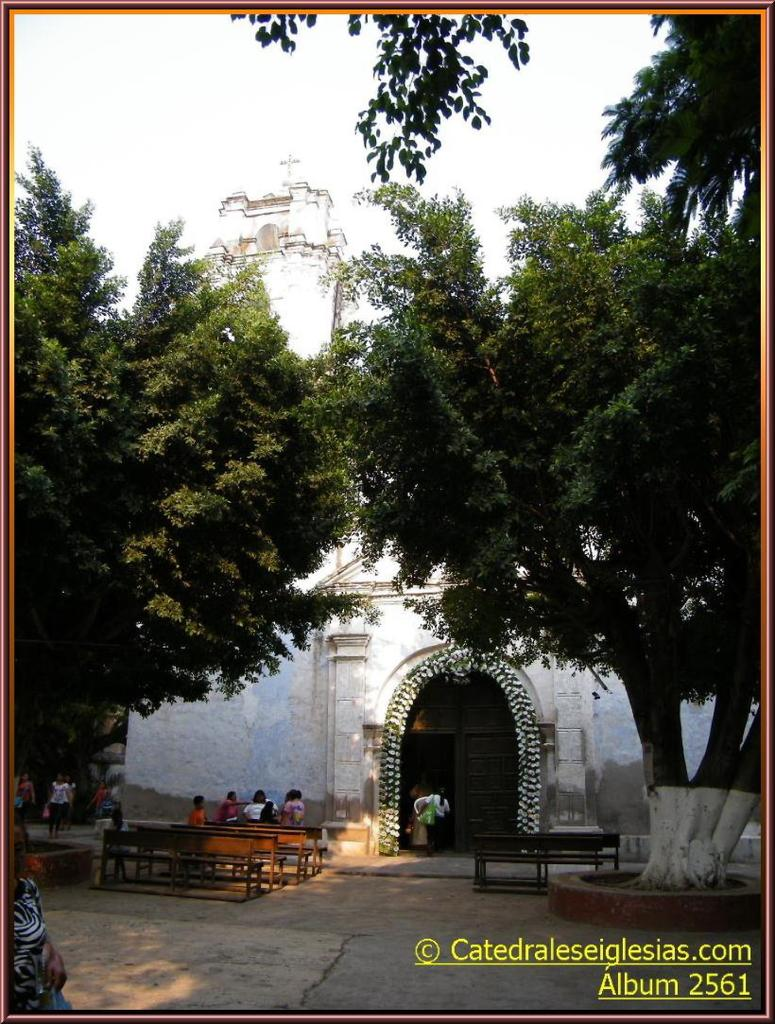What can be found in the image that contains written information? There is text in the image. What type of natural elements are present in the image? There are trees in the image. What type of man-made structure is visible in the image? There is a building in the image. What are the people in the image doing? There is a group of people sitting or lying on the floor in the image. What type of seating is available in the image? There are benches in the image. What is visible at the top of the image? The sky is visible at the top of the image. How is the image displayed? The image appears to be in a photo frame. Can you tell me how many umbrellas are being used by the group of people in the image? There is no mention of umbrellas in the image; the group of people is on the floor, and no umbrellas are visible. What type of request is being made by the people in the image? There is no indication of a request being made in the image; the people are simply sitting or lying on the floor. 